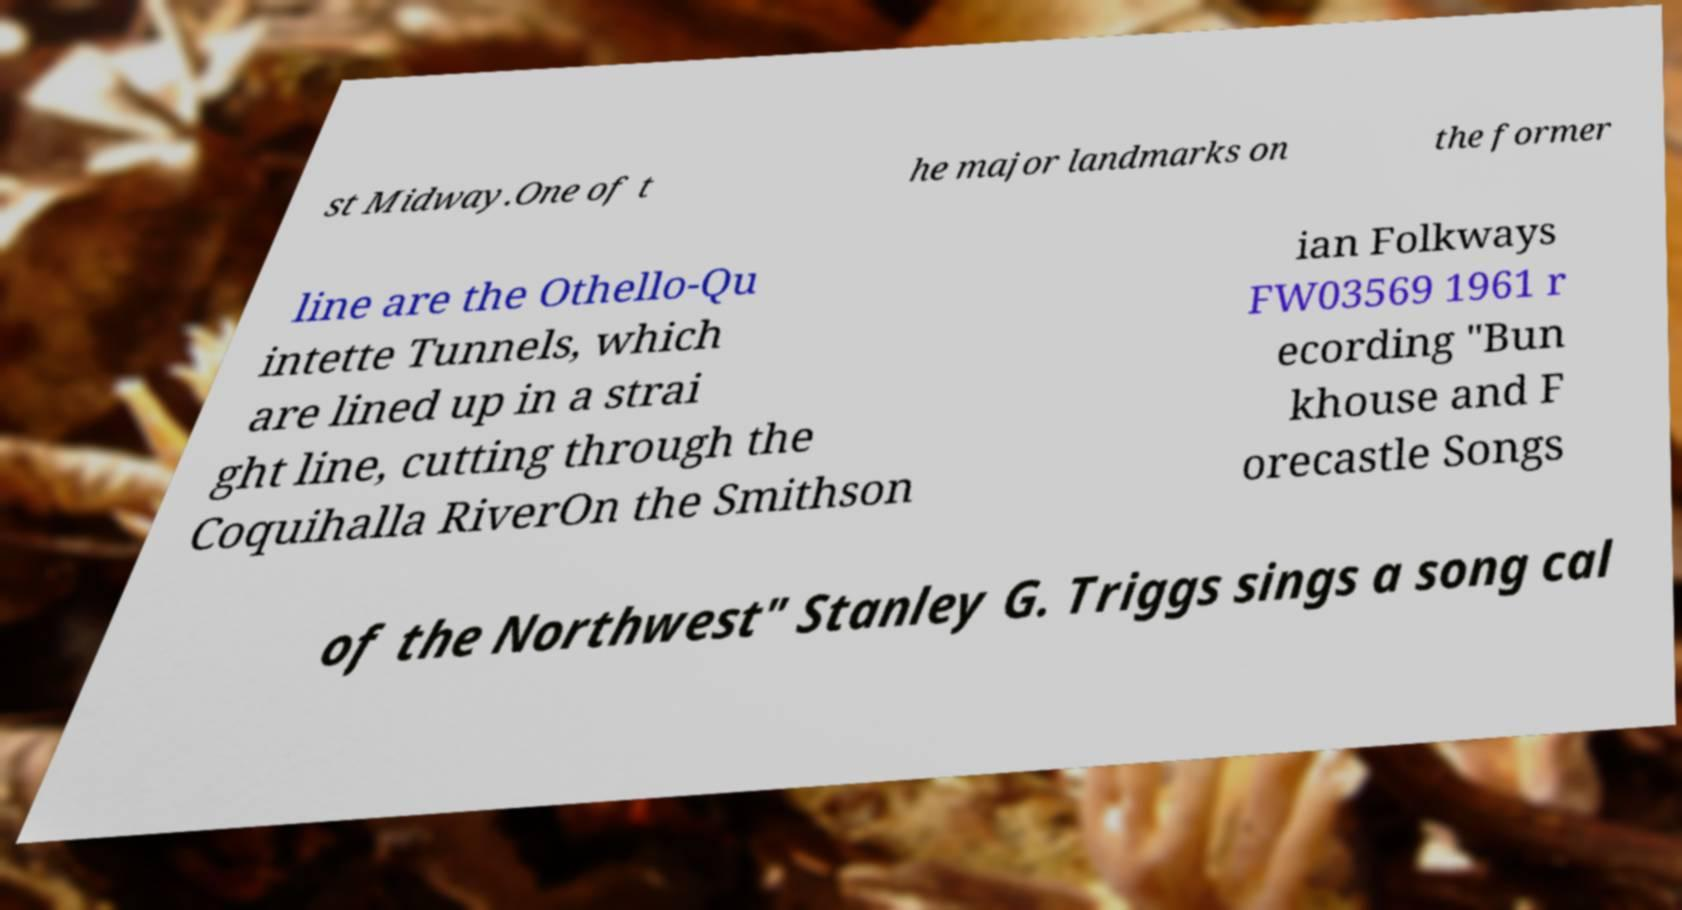I need the written content from this picture converted into text. Can you do that? st Midway.One of t he major landmarks on the former line are the Othello-Qu intette Tunnels, which are lined up in a strai ght line, cutting through the Coquihalla RiverOn the Smithson ian Folkways FW03569 1961 r ecording "Bun khouse and F orecastle Songs of the Northwest" Stanley G. Triggs sings a song cal 